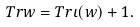Convert formula to latex. <formula><loc_0><loc_0><loc_500><loc_500>T r w = T r \iota ( w ) + 1 .</formula> 